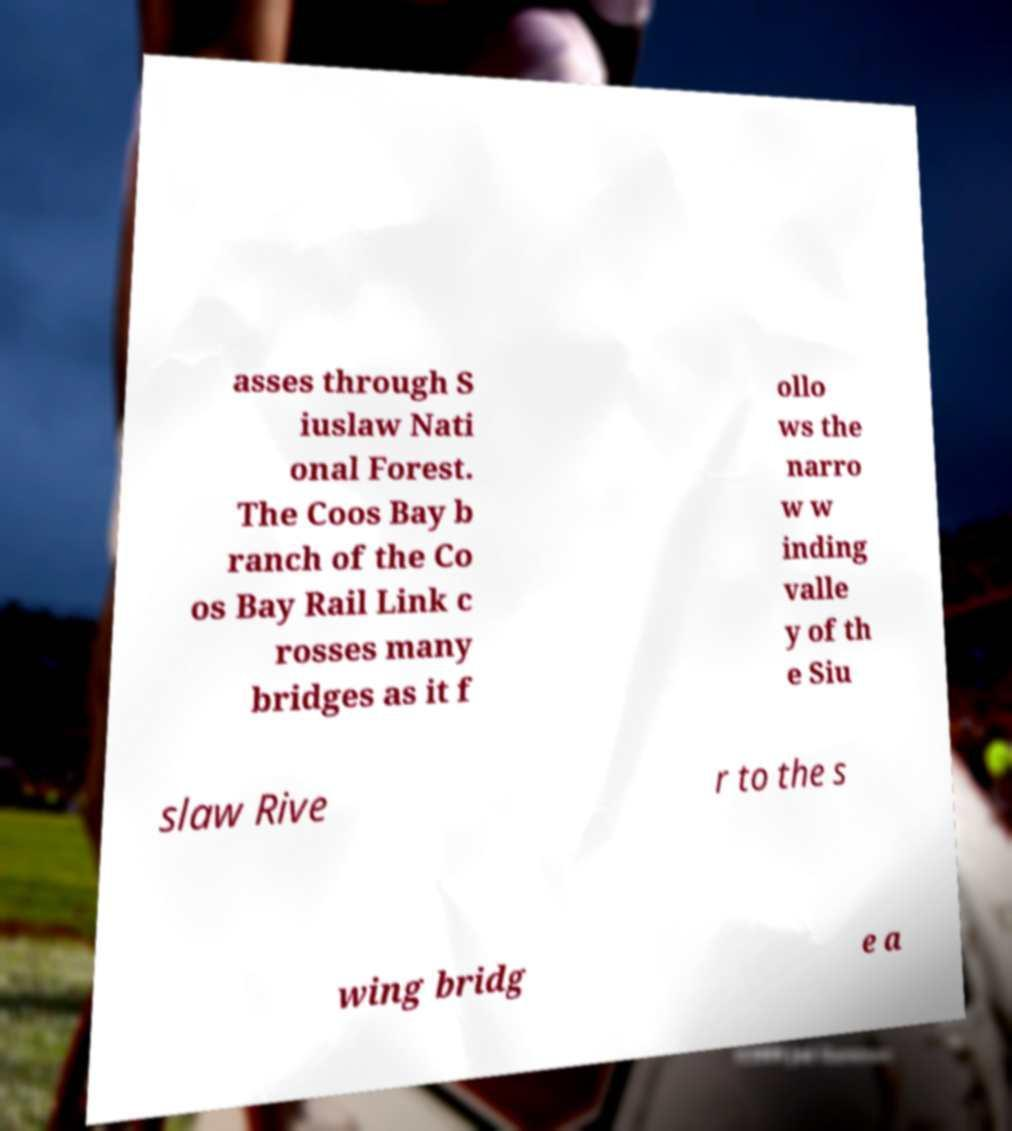Please read and relay the text visible in this image. What does it say? asses through S iuslaw Nati onal Forest. The Coos Bay b ranch of the Co os Bay Rail Link c rosses many bridges as it f ollo ws the narro w w inding valle y of th e Siu slaw Rive r to the s wing bridg e a 